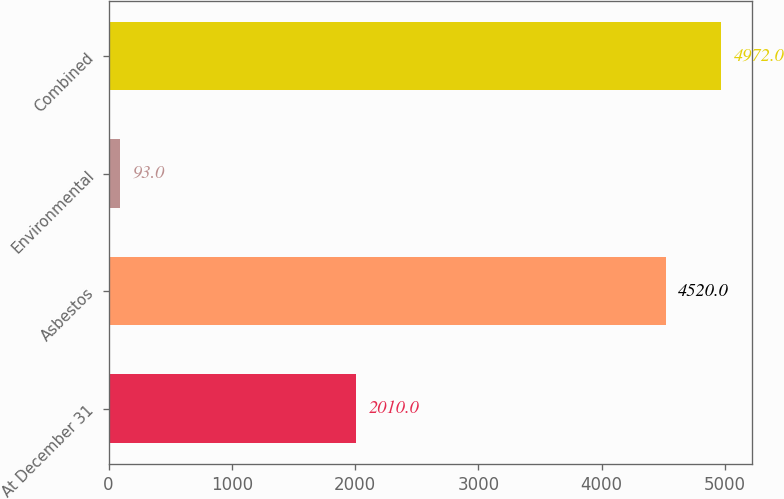Convert chart. <chart><loc_0><loc_0><loc_500><loc_500><bar_chart><fcel>At December 31<fcel>Asbestos<fcel>Environmental<fcel>Combined<nl><fcel>2010<fcel>4520<fcel>93<fcel>4972<nl></chart> 